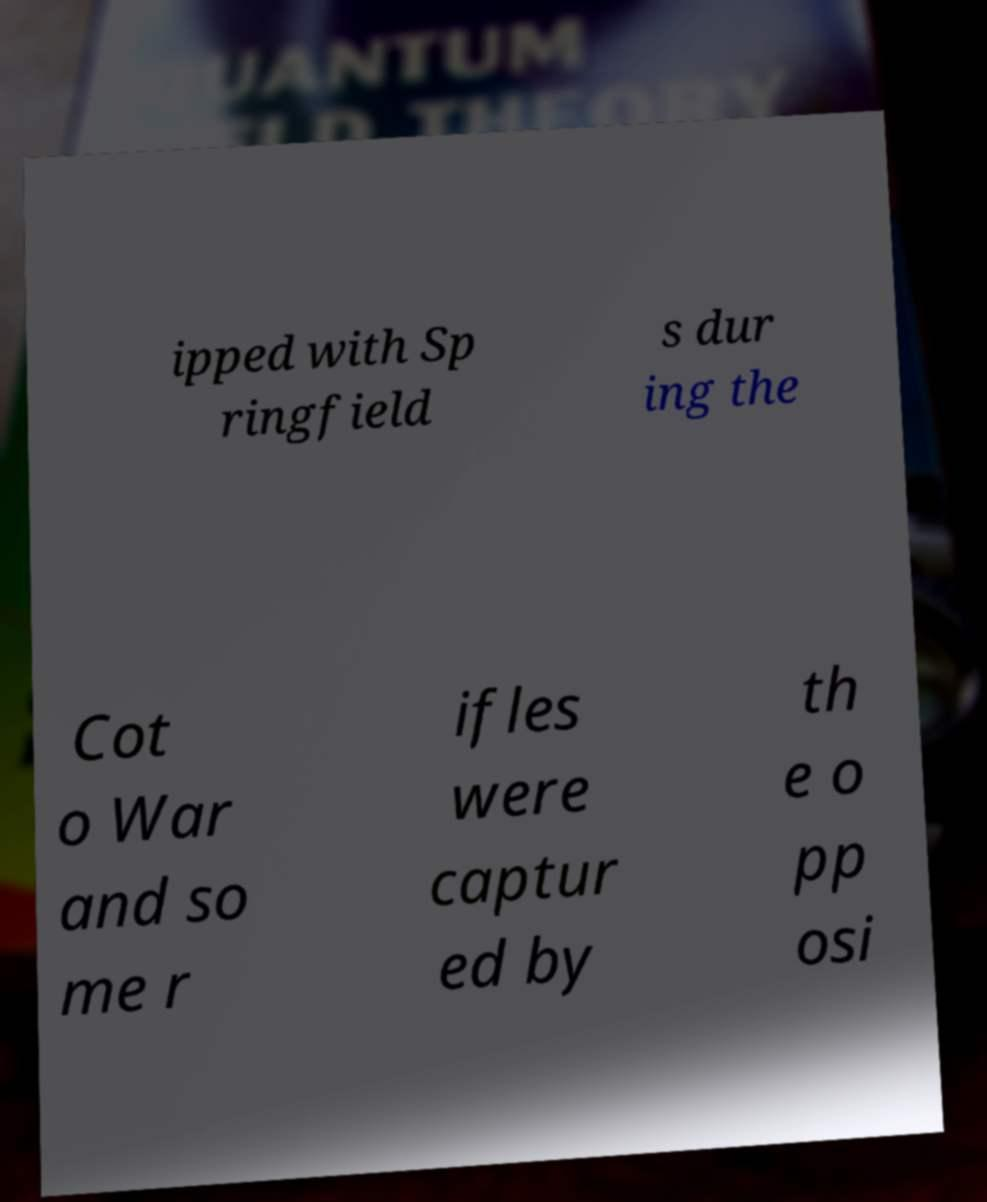There's text embedded in this image that I need extracted. Can you transcribe it verbatim? ipped with Sp ringfield s dur ing the Cot o War and so me r ifles were captur ed by th e o pp osi 